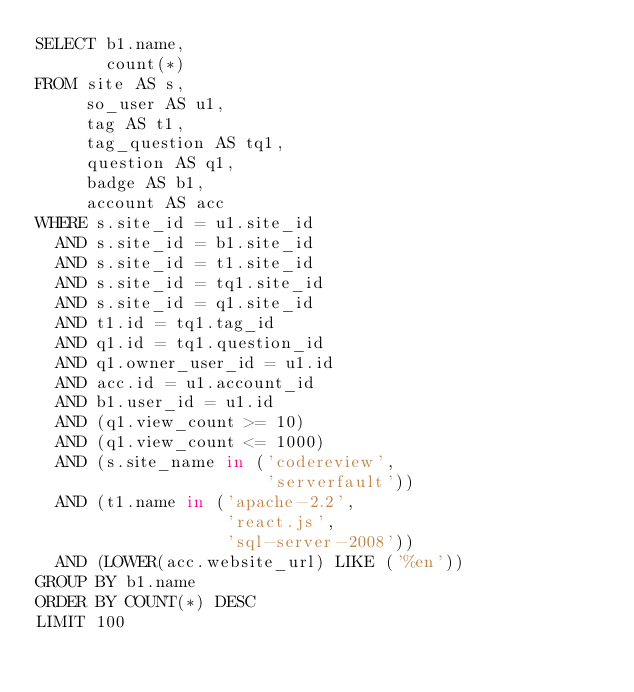Convert code to text. <code><loc_0><loc_0><loc_500><loc_500><_SQL_>SELECT b1.name,
       count(*)
FROM site AS s,
     so_user AS u1,
     tag AS t1,
     tag_question AS tq1,
     question AS q1,
     badge AS b1,
     account AS acc
WHERE s.site_id = u1.site_id
  AND s.site_id = b1.site_id
  AND s.site_id = t1.site_id
  AND s.site_id = tq1.site_id
  AND s.site_id = q1.site_id
  AND t1.id = tq1.tag_id
  AND q1.id = tq1.question_id
  AND q1.owner_user_id = u1.id
  AND acc.id = u1.account_id
  AND b1.user_id = u1.id
  AND (q1.view_count >= 10)
  AND (q1.view_count <= 1000)
  AND (s.site_name in ('codereview',
                       'serverfault'))
  AND (t1.name in ('apache-2.2',
                   'react.js',
                   'sql-server-2008'))
  AND (LOWER(acc.website_url) LIKE ('%en'))
GROUP BY b1.name
ORDER BY COUNT(*) DESC
LIMIT 100</code> 